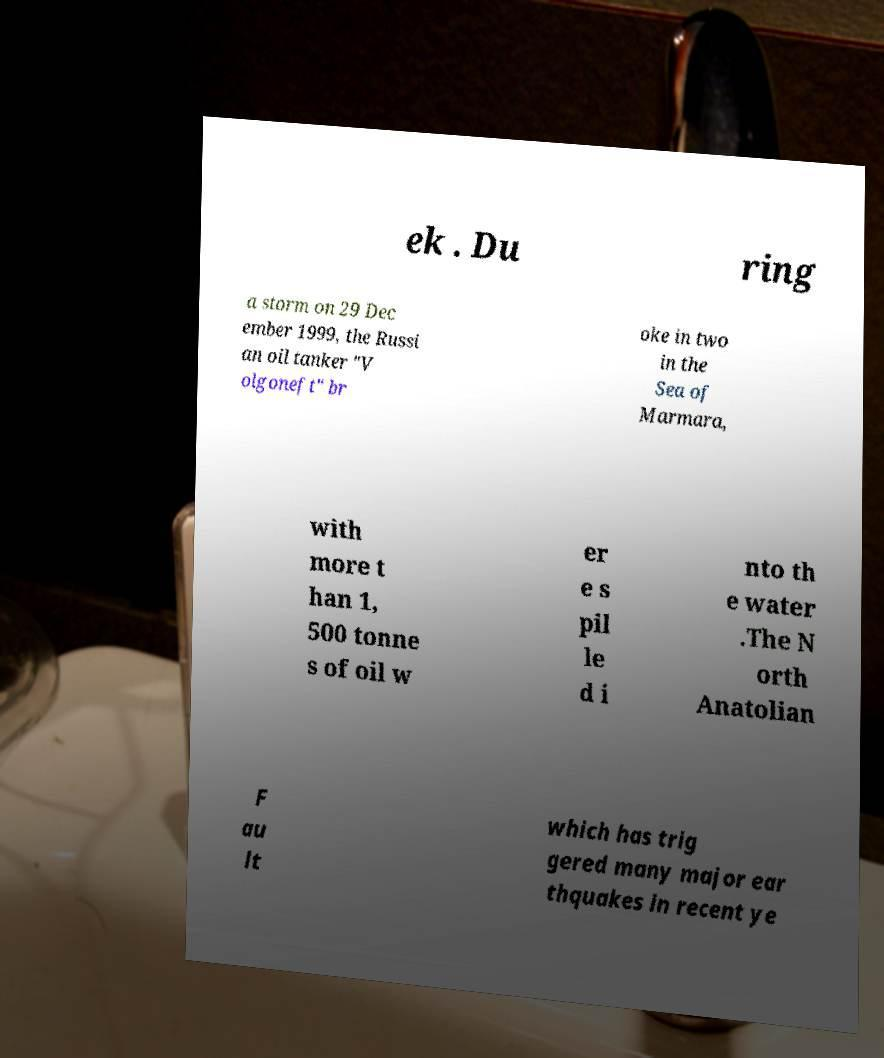Can you accurately transcribe the text from the provided image for me? ek . Du ring a storm on 29 Dec ember 1999, the Russi an oil tanker "V olgoneft" br oke in two in the Sea of Marmara, with more t han 1, 500 tonne s of oil w er e s pil le d i nto th e water .The N orth Anatolian F au lt which has trig gered many major ear thquakes in recent ye 